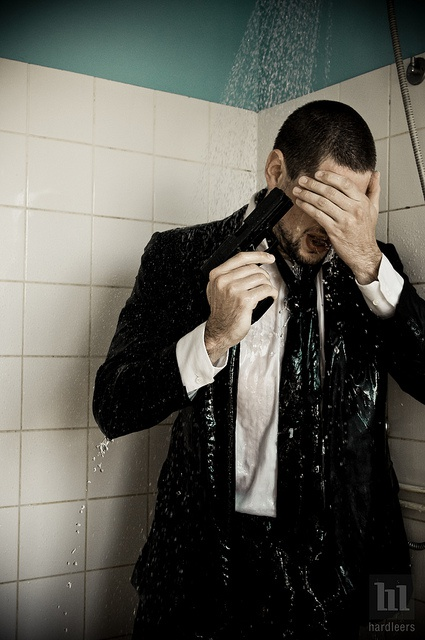Describe the objects in this image and their specific colors. I can see people in black, darkgray, lightgray, and gray tones and tie in black, gray, darkgray, and teal tones in this image. 